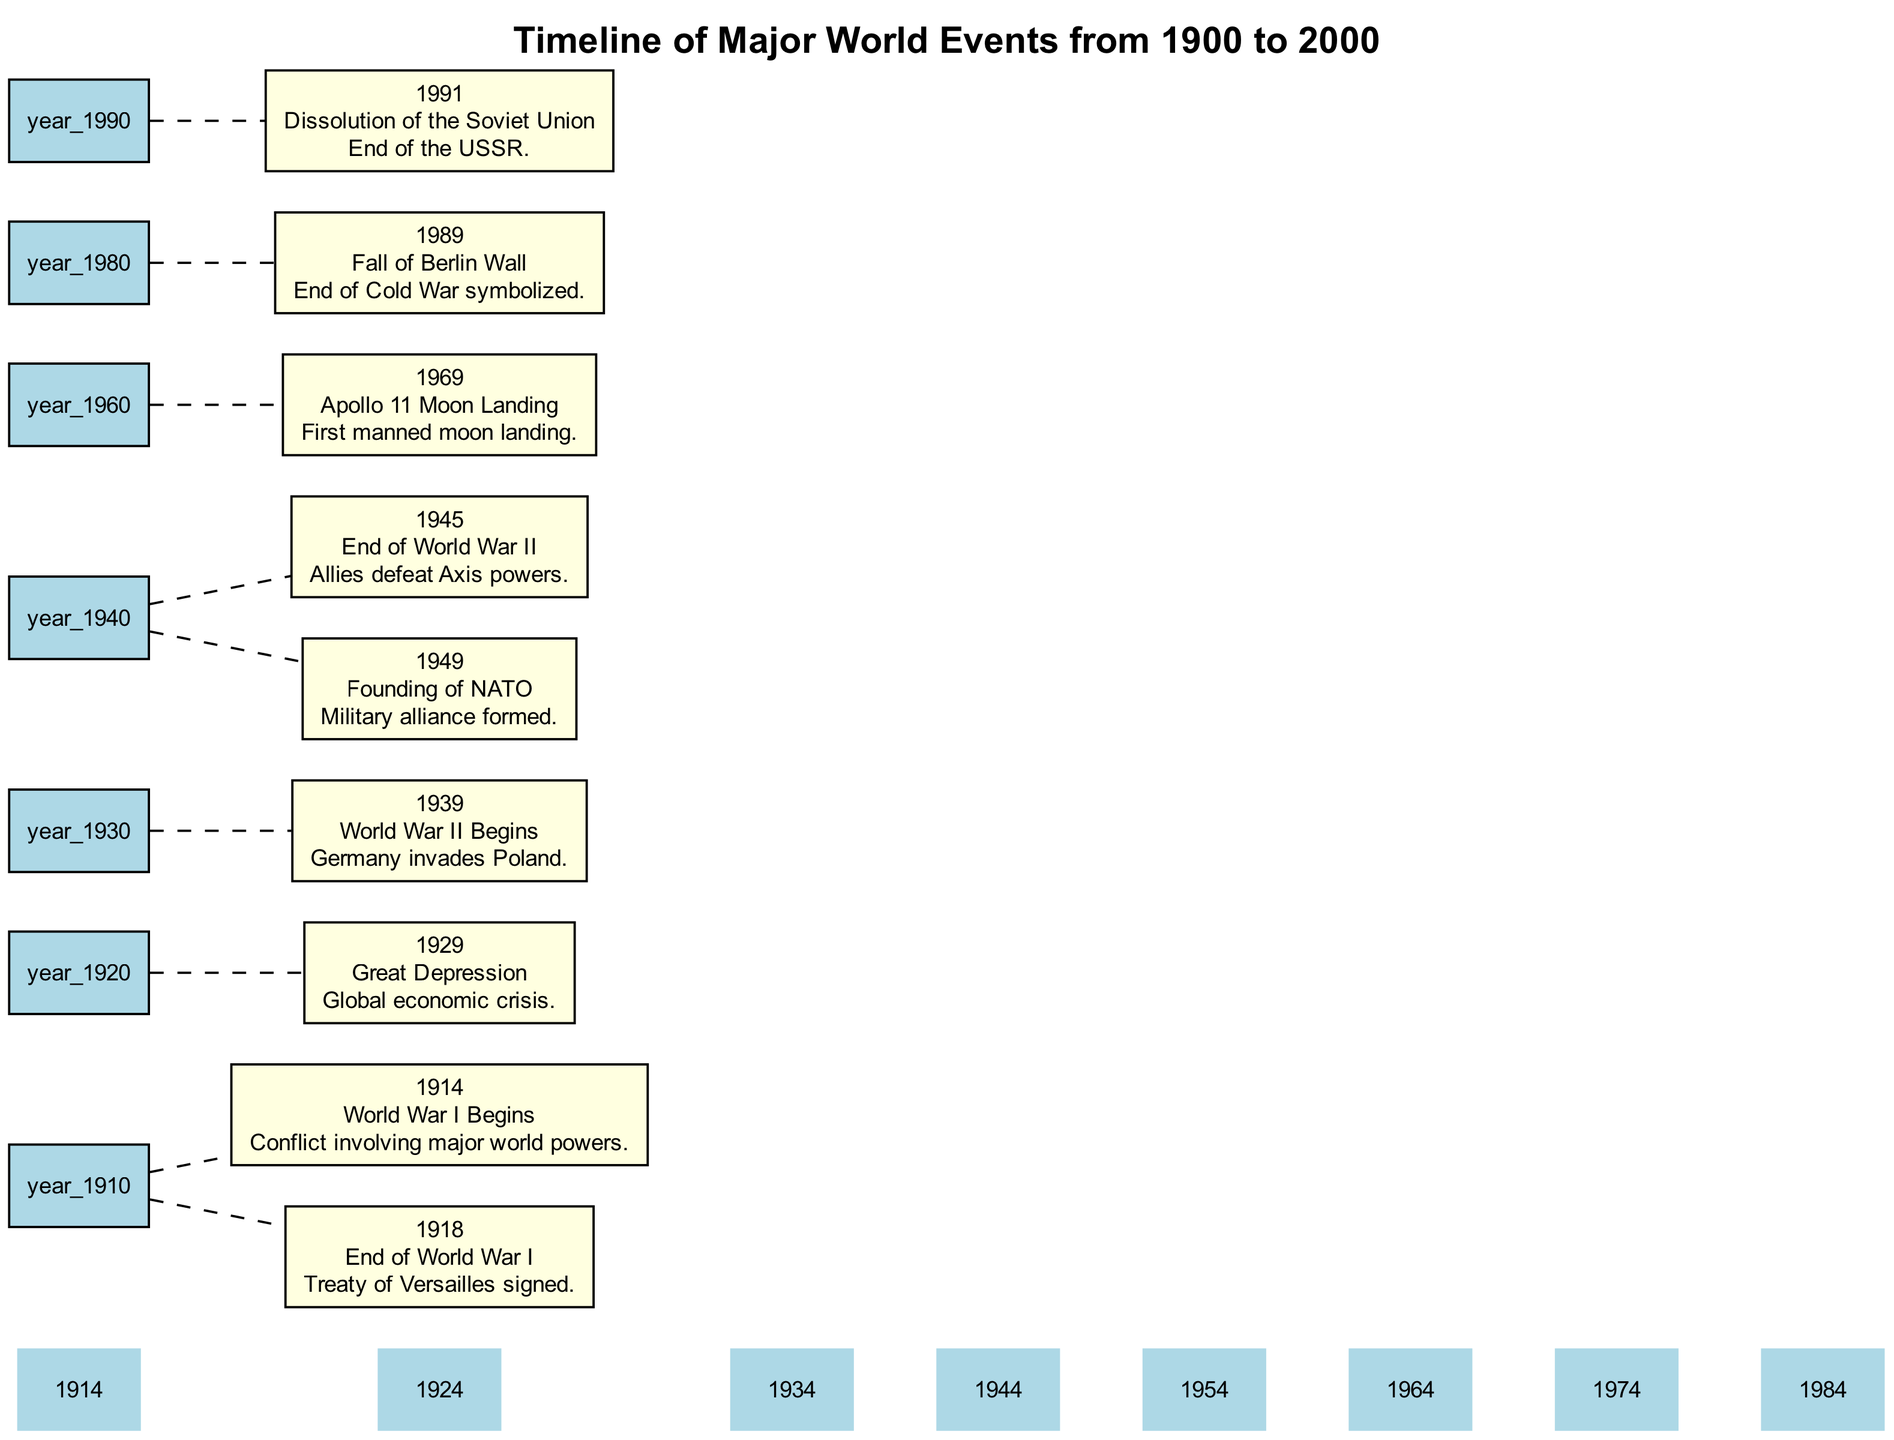What major event occurred in 1914? The diagram shows that in 1914, "World War I Begins" is the event listed. It specifically names this conflict involving major world powers.
Answer: World War I Begins How many major events are documented in this diagram? By counting the events listed in the annotation data, there are a total of 9 major events documented from 1900 to 2000.
Answer: 9 What was the event marked by the year 1945? The diagram indicates that in 1945, the event "End of World War II" occurred, marking the defeat of the Axis powers by the Allies.
Answer: End of World War II Which event signifies the end of the Cold War? According to the diagram, the "Fall of Berlin Wall" in 1989 is noted as the event that symbolizes the end of the Cold War.
Answer: Fall of Berlin Wall In what year did the Apollo 11 Moon Landing take place? Looking at the timeline, the event of "Apollo 11 Moon Landing" is recorded in 1969, marking the first manned moon landing.
Answer: 1969 What events are listed between 1939 and 1945? The diagram contains two key events in this range: in 1939, "World War II Begins," and in 1945, "End of World War II." These events describe the start and end of the major conflict.
Answer: World War II Begins, End of World War II What year marks the founding of NATO? Searching through the annotations in the diagram reveals that NATO was founded in 1949.
Answer: 1949 Which event occurred directly before the Dissolution of the Soviet Union? According to the timeline, the event that occurred immediately before the "Dissolution of the Soviet Union" in 1991 is the "Fall of Berlin Wall" in 1989.
Answer: Fall of Berlin Wall What is the significance of the Treaty of Versailles according to the diagram? The diagram annotates the end of World War I in 1918 with the signing of the "Treaty of Versailles," which is crucial for concluding that conflict.
Answer: Treaty of Versailles 